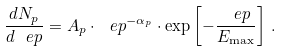<formula> <loc_0><loc_0><loc_500><loc_500>\frac { d N _ { p } } { d \ e p } = A _ { p } \cdot { \ e p } ^ { - \alpha _ { p } } \cdot \exp \left [ - \frac { \ e p } { E _ { \max } } \right ] \, .</formula> 